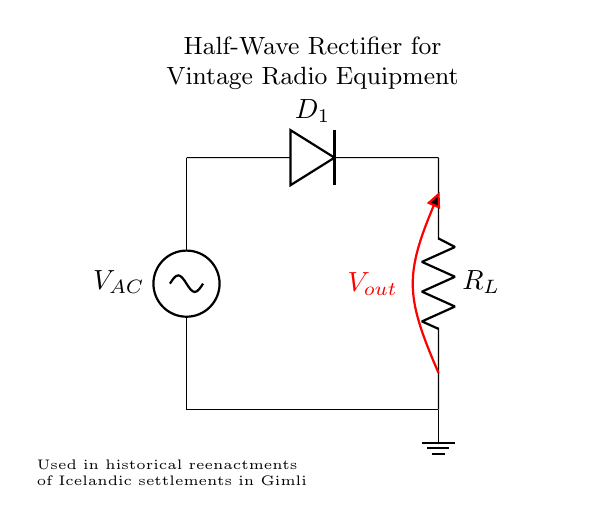What is the component labeled D1? D1 is a diode, which is used to allow current to flow in one direction only, thus facilitating the rectification process.
Answer: diode What does R_L represent in this circuit? R_L stands for the load resistor, which represents the component that consumes power from the rectified voltage in the circuit.
Answer: load resistor How many diodes are used in this circuit? There is a single diode in this half-wave rectifier circuit, responsible for converting AC voltage to DC voltage.
Answer: one What type of rectifier is shown in this circuit? The circuit is a half-wave rectifier, which is characterized by using only one diode to conduct current during one half of the AC cycle.
Answer: half-wave What is the role of the AC voltage source in this circuit? The AC voltage source provides the alternating current necessary for the rectification process to occur in the circuit.
Answer: provide alternating current What is the direction of current flow during the positive cycle? During the positive cycle of the AC voltage, the current flows from the AC source through the diode and into the load resistor.
Answer: from AC source to load resistor What type of signal is V_out compared to V_AC? V_out is a pulsating direct current signal that varies in magnitude, as opposed to the alternating current nature of V_AC, which continuously changes direction.
Answer: pulsating direct current 